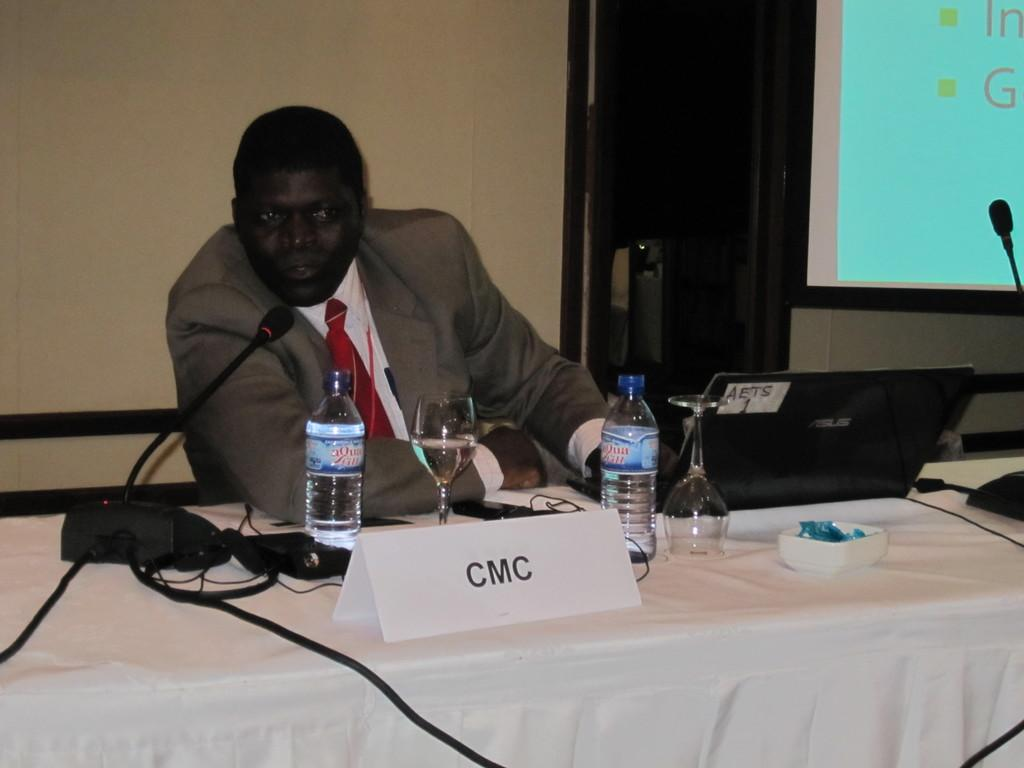What is the person in the image doing? The person is sitting on a chair in the image. What is located near the person? There is a table in the image. What items can be seen on the table? There are bottles, glasses, and a bowl on the table. What electronic device is present in the image? There is a screen in the image. What object is used for amplifying sound? There is a microphone (mike) in the image. What type of pollution is being caused by the person in the image? There is no indication of pollution in the image; it only shows a person sitting on a chair, a table with items, a screen, and a microphone. 